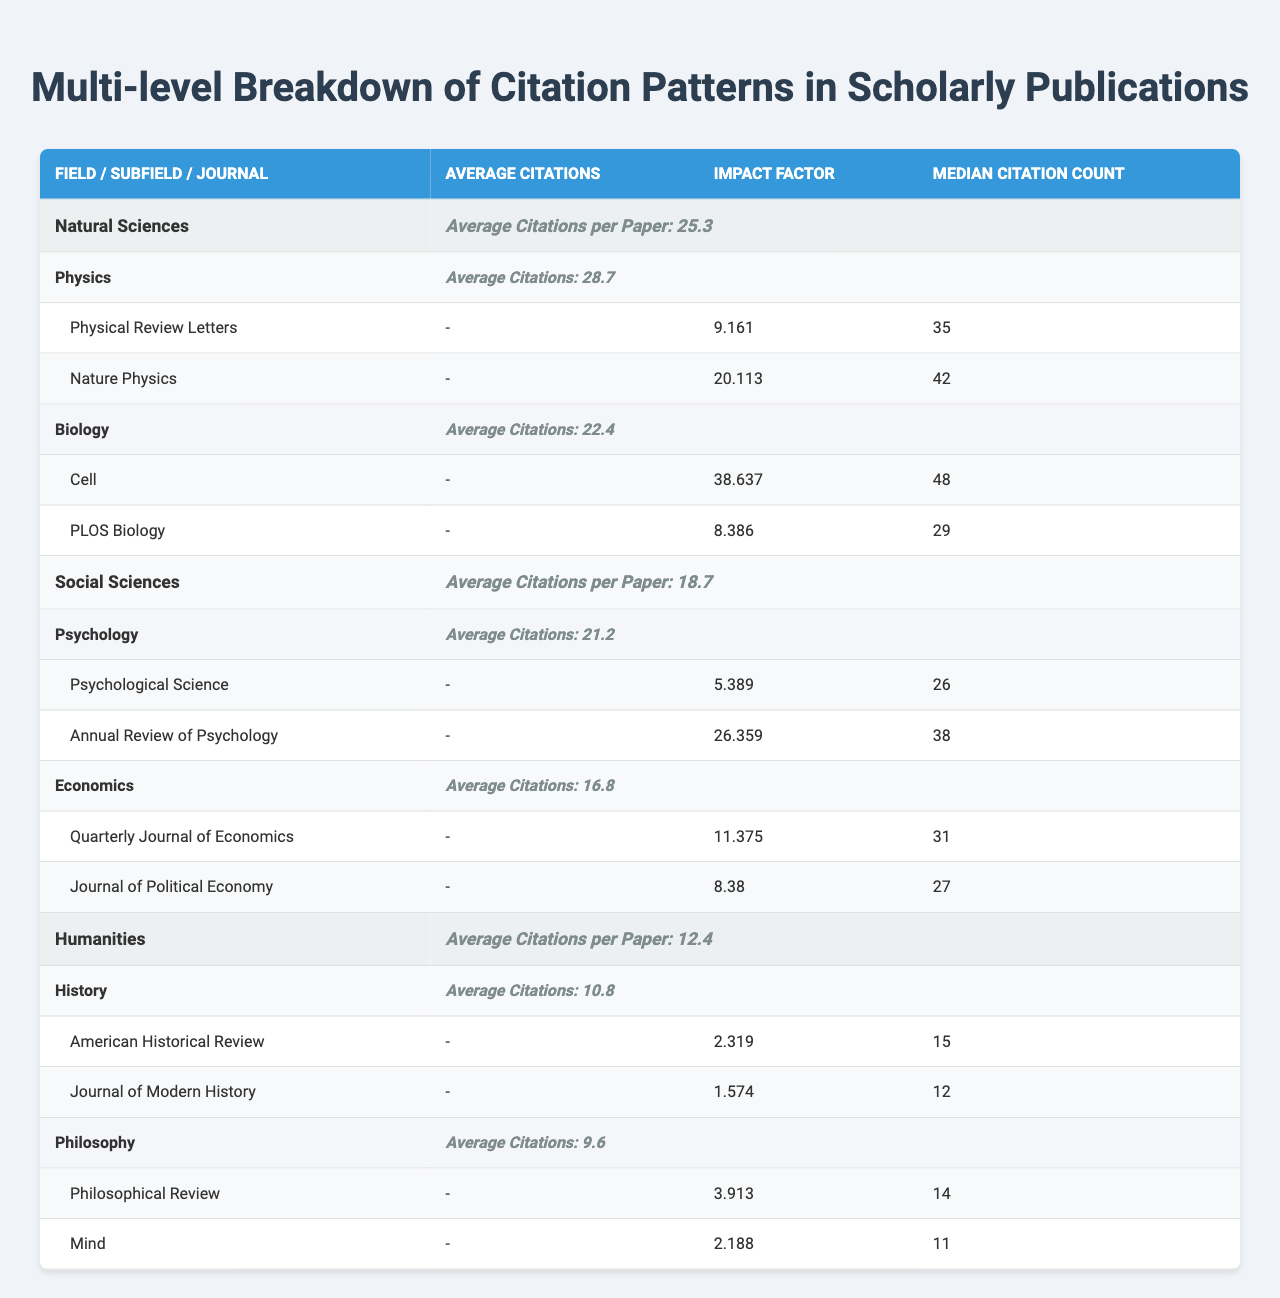What is the average number of citations per paper in the field of Natural Sciences? The table shows that the average citations per paper in the field of Natural Sciences is listed as 25.3.
Answer: 25.3 Which subfield in Social Sciences has the highest average citations? By looking at the subfields under Social Sciences, Psychology has an average of 21.2 citations while Economics has 16.8, making Psychology the higher one.
Answer: Psychology What is the impact factor of the journal "Cell"? The impact factor for the journal "Cell" is stated in the table as 38.637.
Answer: 38.637 How many subfields are listed under Humanities? The table indicates that there are two subfields listed under Humanities: History and Philosophy.
Answer: 2 What is the median citation count for the journal "Physical Review Letters"? According to the table, the median citation count for "Physical Review Letters" is 35.
Answer: 35 What is the difference in average citations per paper between Natural Sciences and Humanities? The average citations per paper in Natural Sciences is 25.3, while in Humanities it is 12.4. The difference is 25.3 - 12.4 = 12.9.
Answer: 12.9 Is the impact factor of "Annual Review of Psychology" greater than 10? The table shows that the impact factor of "Annual Review of Psychology" is 26.359, which is indeed greater than 10.
Answer: Yes Which field has the lowest average citations per paper? Comparing the average citations across all fields, Humanities has the lowest average at 12.4 citations per paper.
Answer: Humanities What is the total average citation count for the top journals listed under the subfield of Biology? The median citation counts for the top journals "Cell" and "PLOS Biology" are 48 and 29, respectively. Their total is 48 + 29 = 77.
Answer: 77 If you combined the average citations of both subfields in Natural Sciences, what would it be? For the subfields in Natural Sciences, Physics has an average of 28.7 citations and Biology has 22.4. The combined average is (28.7 + 22.4) / 2 = 26.55.
Answer: 26.55 What is the median citation count for journals listed under the subfield of Philosophy? The median citation counts for the journals "Philosophical Review" and "Mind" are 14 and 11 respectively. The overall median for Philosophy's top journals would be 12.5.
Answer: 12.5 